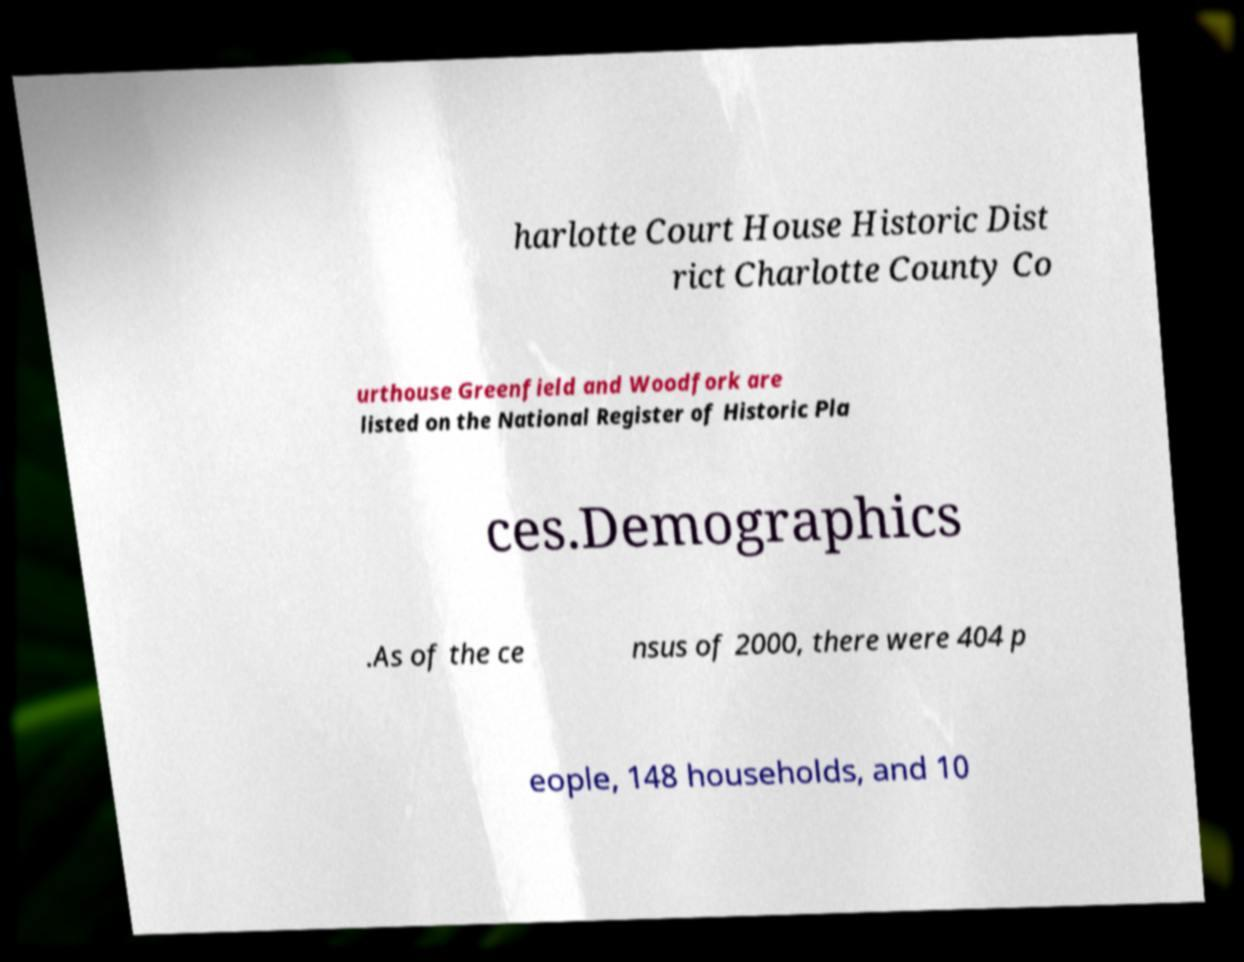I need the written content from this picture converted into text. Can you do that? harlotte Court House Historic Dist rict Charlotte County Co urthouse Greenfield and Woodfork are listed on the National Register of Historic Pla ces.Demographics .As of the ce nsus of 2000, there were 404 p eople, 148 households, and 10 